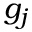<formula> <loc_0><loc_0><loc_500><loc_500>g _ { j }</formula> 